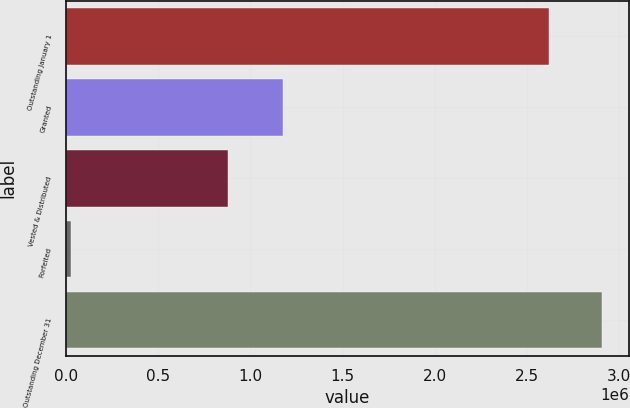Convert chart. <chart><loc_0><loc_0><loc_500><loc_500><bar_chart><fcel>Outstanding January 1<fcel>Granted<fcel>Vested & Distributed<fcel>Forfeited<fcel>Outstanding December 31<nl><fcel>2.62151e+06<fcel>1.1745e+06<fcel>877111<fcel>25623<fcel>2.90828e+06<nl></chart> 